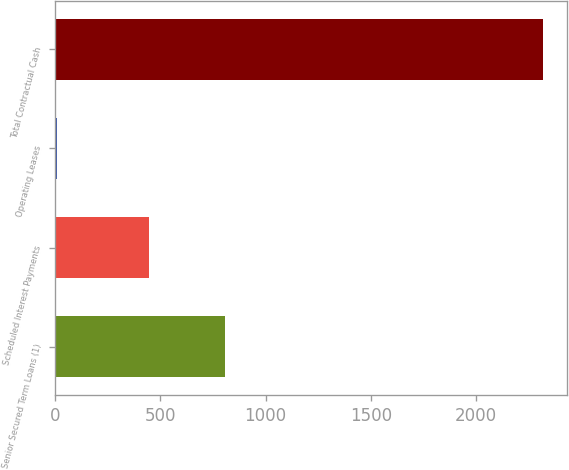<chart> <loc_0><loc_0><loc_500><loc_500><bar_chart><fcel>Senior Secured Term Loans (1)<fcel>Scheduled Interest Payments<fcel>Operating Leases<fcel>Total Contractual Cash<nl><fcel>805.5<fcel>448.8<fcel>10.8<fcel>2315.1<nl></chart> 